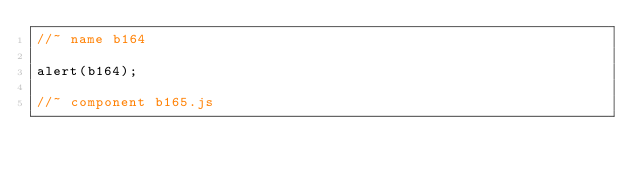<code> <loc_0><loc_0><loc_500><loc_500><_JavaScript_>//~ name b164

alert(b164);

//~ component b165.js

</code> 